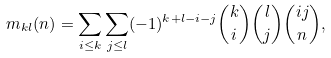Convert formula to latex. <formula><loc_0><loc_0><loc_500><loc_500>m _ { k l } ( n ) = \sum _ { i \leq k } \sum _ { j \leq l } ( - 1 ) ^ { k + l - i - j } { k \choose i } { l \choose j } { i j \choose n } ,</formula> 